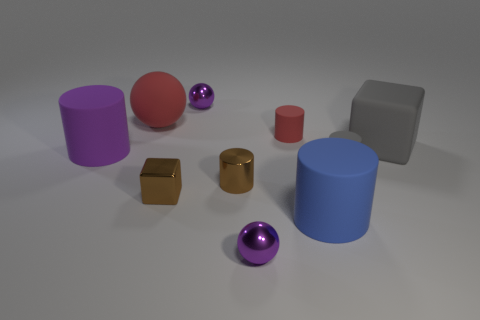Do the cylinder in front of the metal cylinder and the small rubber thing that is behind the tiny gray cylinder have the same color?
Make the answer very short. No. How many brown things are tiny metal blocks or matte cubes?
Provide a short and direct response. 1. Is the number of small metal cubes that are on the left side of the tiny brown cube less than the number of brown shiny cubes in front of the big gray rubber block?
Your answer should be very brief. Yes. Are there any metallic cylinders of the same size as the red ball?
Your response must be concise. No. Do the shiny thing that is in front of the brown shiny block and the big red sphere have the same size?
Make the answer very short. No. Is the number of purple spheres greater than the number of purple cylinders?
Your answer should be very brief. Yes. Are there any brown matte objects that have the same shape as the big blue rubber object?
Offer a terse response. No. The large blue rubber thing that is in front of the small gray cylinder has what shape?
Offer a very short reply. Cylinder. How many metallic blocks are behind the gray object that is to the right of the tiny gray thing that is in front of the big red rubber thing?
Keep it short and to the point. 0. There is a shiny ball that is behind the metal cylinder; is it the same color as the rubber ball?
Make the answer very short. No. 